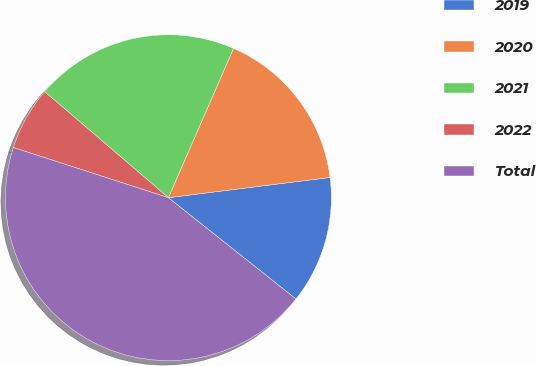Convert chart. <chart><loc_0><loc_0><loc_500><loc_500><pie_chart><fcel>2019<fcel>2020<fcel>2021<fcel>2022<fcel>Total<nl><fcel>12.67%<fcel>16.47%<fcel>20.27%<fcel>6.3%<fcel>44.3%<nl></chart> 